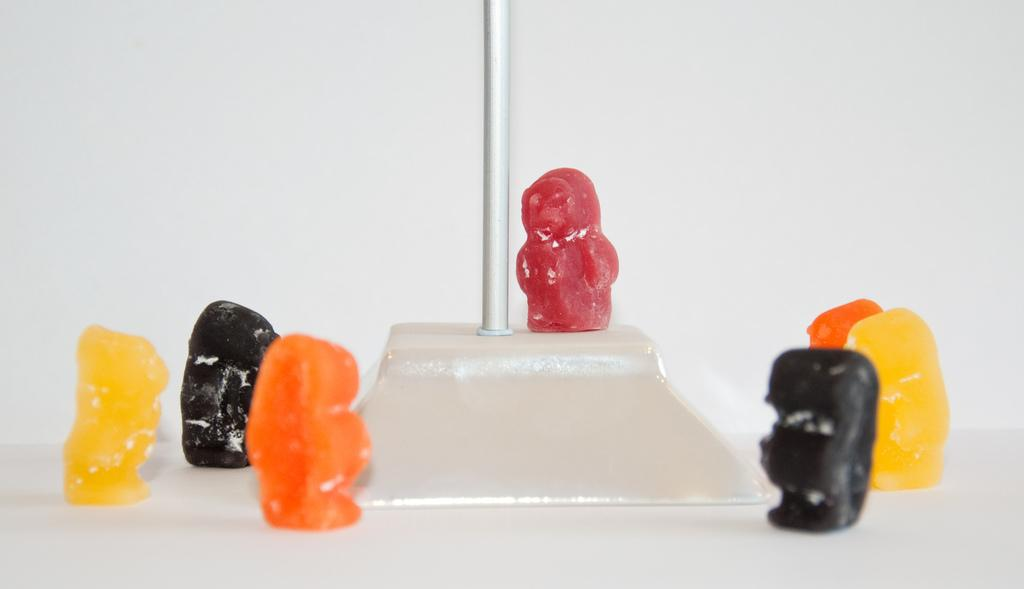What type of food items are present in the image? There are candies in the image. Can you describe the colors of the candies? The candies are of black, orange, red, red, and yellow colors. What is the central object in the image? There is a pole-like object in the middle of the image. What type of pain can be seen in the image? There is no pain present in the image; it features candies and a pole-like object. Can you describe the veins in the candies? There are no veins in the candies, as they are not living organisms. 